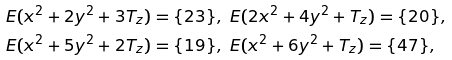<formula> <loc_0><loc_0><loc_500><loc_500>& E ( x ^ { 2 } + 2 y ^ { 2 } + 3 T _ { z } ) = \{ 2 3 \} , \ E ( 2 x ^ { 2 } + 4 y ^ { 2 } + T _ { z } ) = \{ 2 0 \} , \\ & E ( x ^ { 2 } + 5 y ^ { 2 } + 2 T _ { z } ) = \{ 1 9 \} , \ E ( x ^ { 2 } + 6 y ^ { 2 } + T _ { z } ) = \{ 4 7 \} ,</formula> 